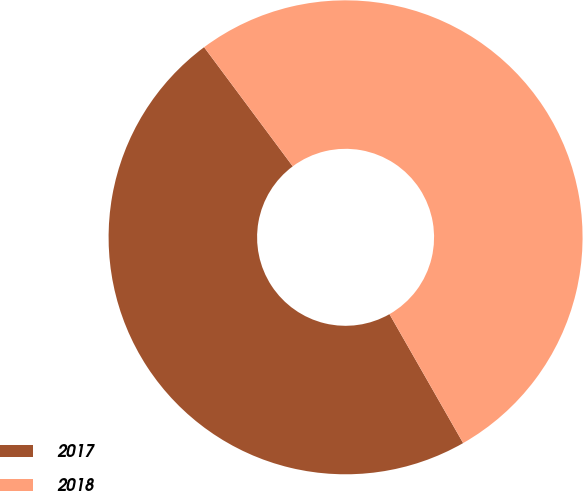<chart> <loc_0><loc_0><loc_500><loc_500><pie_chart><fcel>2017<fcel>2018<nl><fcel>48.08%<fcel>51.92%<nl></chart> 